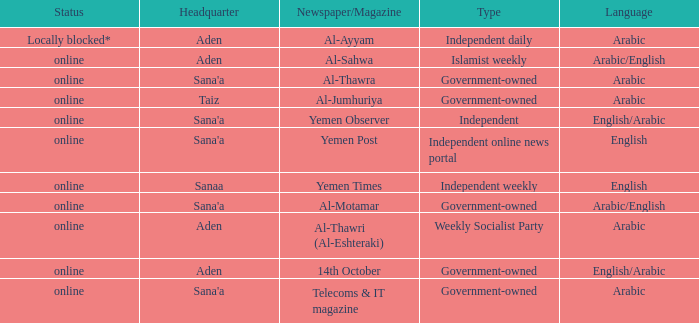What is Headquarter, when Type is Government-Owned, and when Newspaper/Magazine is Al-Jumhuriya? Taiz. 